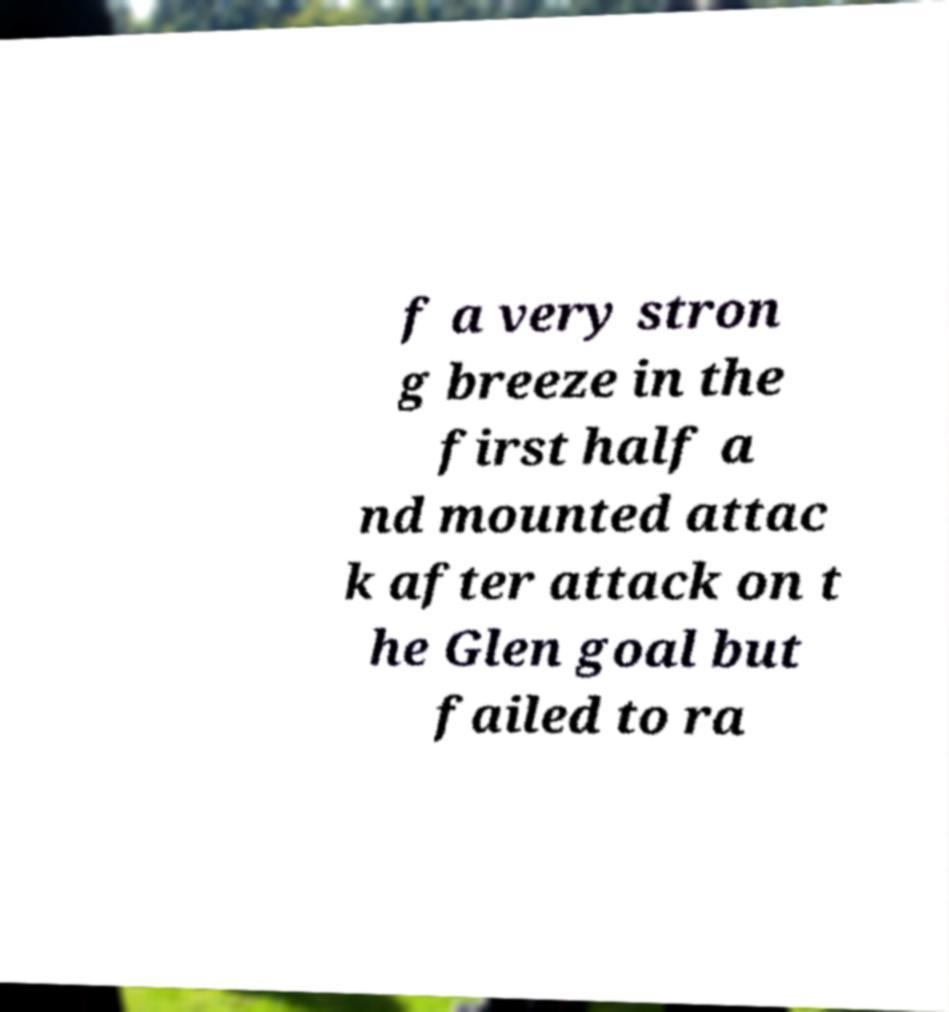Please identify and transcribe the text found in this image. f a very stron g breeze in the first half a nd mounted attac k after attack on t he Glen goal but failed to ra 